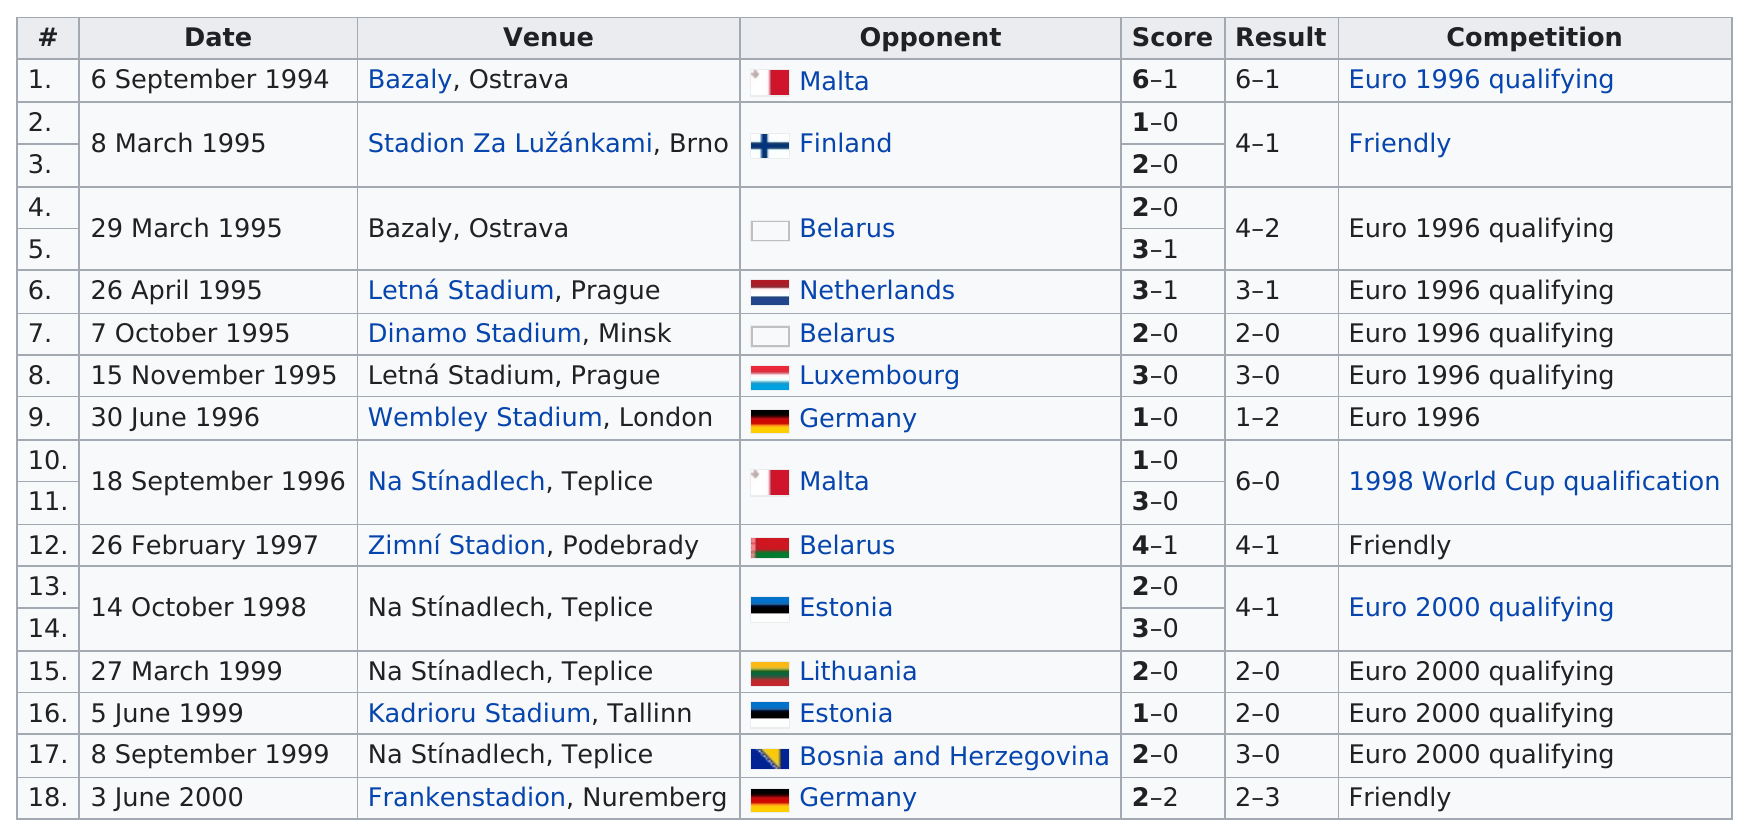Identify some key points in this picture. The Czech Republic and Germany have played each other 2 times in their football history. There are 4 Euro 2000 qualifying competitions listed. The Czech Republic scored the most goals against Malta. The Belarusian opponent was defeated by a score of 2-0, except for the Lithuanian and Estonian opponents who also suffered the same result. In 1999, a total of three games took place. 